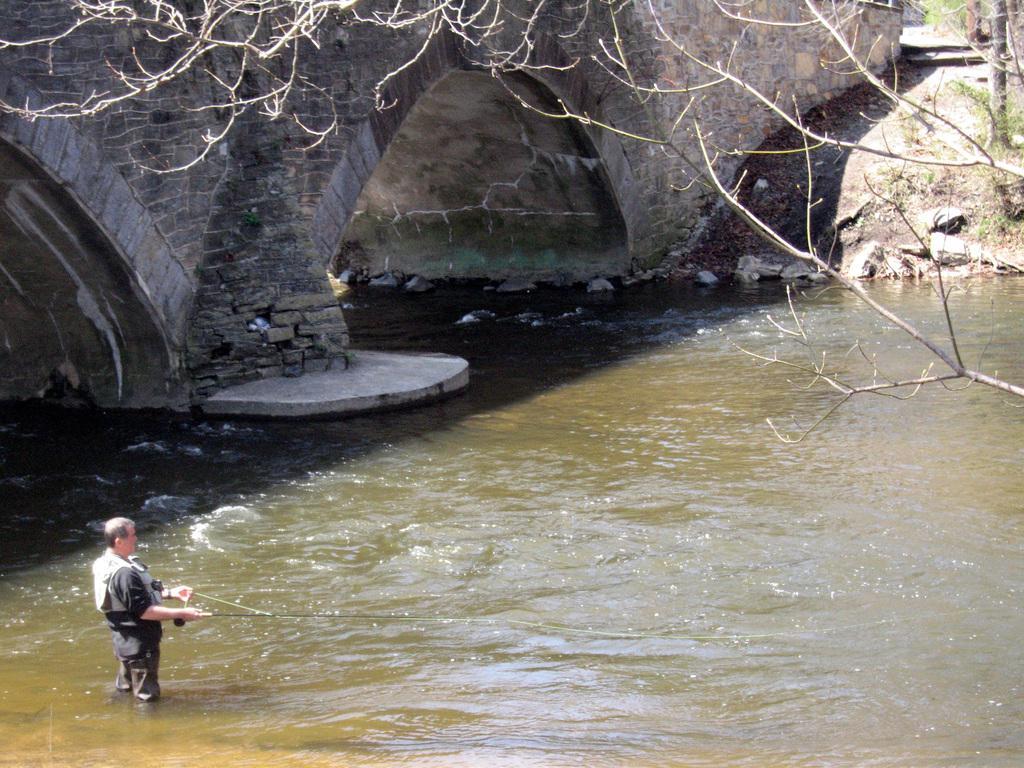Describe this image in one or two sentences. On the left side a man is standing in the water and fishing. He wore black color dress, it looks like a bridge, on the right side there is a tree. 